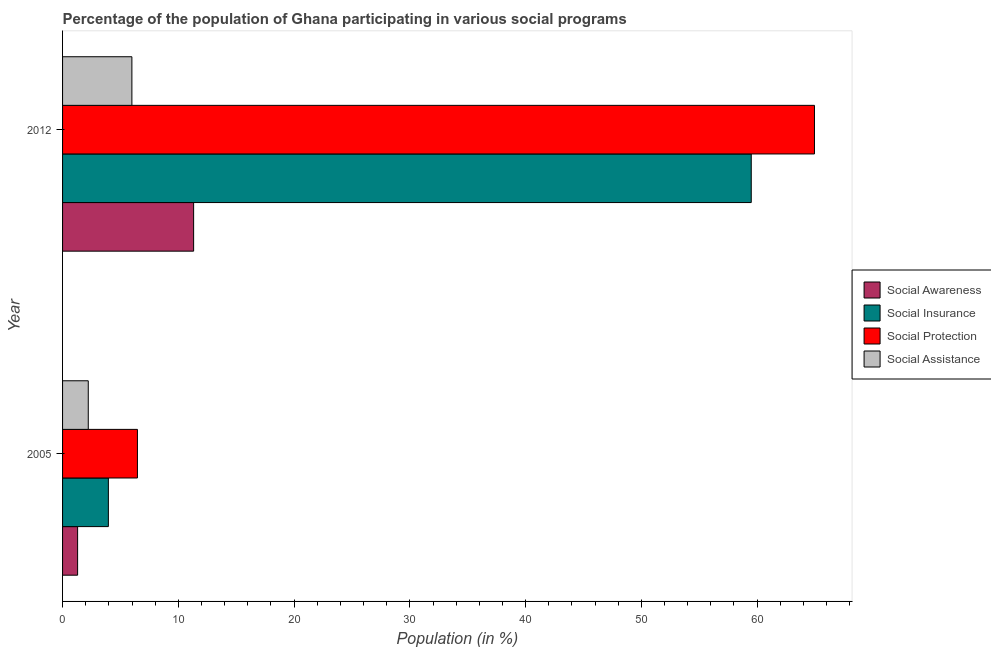How many different coloured bars are there?
Make the answer very short. 4. How many groups of bars are there?
Provide a short and direct response. 2. How many bars are there on the 1st tick from the top?
Give a very brief answer. 4. What is the participation of population in social protection programs in 2005?
Your answer should be very brief. 6.47. Across all years, what is the maximum participation of population in social protection programs?
Offer a terse response. 64.95. Across all years, what is the minimum participation of population in social awareness programs?
Offer a terse response. 1.3. In which year was the participation of population in social awareness programs maximum?
Provide a short and direct response. 2012. In which year was the participation of population in social protection programs minimum?
Ensure brevity in your answer.  2005. What is the total participation of population in social protection programs in the graph?
Give a very brief answer. 71.42. What is the difference between the participation of population in social insurance programs in 2005 and that in 2012?
Give a very brief answer. -55.53. What is the difference between the participation of population in social awareness programs in 2012 and the participation of population in social insurance programs in 2005?
Keep it short and to the point. 7.36. What is the average participation of population in social assistance programs per year?
Your answer should be compact. 4.11. In the year 2005, what is the difference between the participation of population in social protection programs and participation of population in social insurance programs?
Give a very brief answer. 2.51. In how many years, is the participation of population in social awareness programs greater than 44 %?
Provide a succinct answer. 0. What is the ratio of the participation of population in social awareness programs in 2005 to that in 2012?
Offer a very short reply. 0.12. What does the 1st bar from the top in 2012 represents?
Make the answer very short. Social Assistance. What does the 2nd bar from the bottom in 2005 represents?
Make the answer very short. Social Insurance. How many bars are there?
Offer a terse response. 8. How many years are there in the graph?
Provide a succinct answer. 2. What is the difference between two consecutive major ticks on the X-axis?
Give a very brief answer. 10. Are the values on the major ticks of X-axis written in scientific E-notation?
Your response must be concise. No. Does the graph contain grids?
Ensure brevity in your answer.  No. Where does the legend appear in the graph?
Offer a terse response. Center right. How many legend labels are there?
Your response must be concise. 4. How are the legend labels stacked?
Ensure brevity in your answer.  Vertical. What is the title of the graph?
Ensure brevity in your answer.  Percentage of the population of Ghana participating in various social programs . What is the Population (in %) of Social Awareness in 2005?
Offer a very short reply. 1.3. What is the Population (in %) of Social Insurance in 2005?
Your response must be concise. 3.96. What is the Population (in %) in Social Protection in 2005?
Give a very brief answer. 6.47. What is the Population (in %) in Social Assistance in 2005?
Give a very brief answer. 2.22. What is the Population (in %) of Social Awareness in 2012?
Your answer should be compact. 11.32. What is the Population (in %) of Social Insurance in 2012?
Offer a very short reply. 59.49. What is the Population (in %) of Social Protection in 2012?
Make the answer very short. 64.95. What is the Population (in %) of Social Assistance in 2012?
Provide a short and direct response. 5.99. Across all years, what is the maximum Population (in %) of Social Awareness?
Offer a very short reply. 11.32. Across all years, what is the maximum Population (in %) in Social Insurance?
Offer a terse response. 59.49. Across all years, what is the maximum Population (in %) of Social Protection?
Offer a terse response. 64.95. Across all years, what is the maximum Population (in %) in Social Assistance?
Give a very brief answer. 5.99. Across all years, what is the minimum Population (in %) of Social Awareness?
Offer a very short reply. 1.3. Across all years, what is the minimum Population (in %) of Social Insurance?
Offer a very short reply. 3.96. Across all years, what is the minimum Population (in %) of Social Protection?
Give a very brief answer. 6.47. Across all years, what is the minimum Population (in %) in Social Assistance?
Give a very brief answer. 2.22. What is the total Population (in %) of Social Awareness in the graph?
Ensure brevity in your answer.  12.62. What is the total Population (in %) of Social Insurance in the graph?
Your response must be concise. 63.45. What is the total Population (in %) in Social Protection in the graph?
Offer a very short reply. 71.42. What is the total Population (in %) in Social Assistance in the graph?
Make the answer very short. 8.21. What is the difference between the Population (in %) in Social Awareness in 2005 and that in 2012?
Your response must be concise. -10.02. What is the difference between the Population (in %) in Social Insurance in 2005 and that in 2012?
Offer a terse response. -55.53. What is the difference between the Population (in %) of Social Protection in 2005 and that in 2012?
Make the answer very short. -58.48. What is the difference between the Population (in %) of Social Assistance in 2005 and that in 2012?
Keep it short and to the point. -3.77. What is the difference between the Population (in %) of Social Awareness in 2005 and the Population (in %) of Social Insurance in 2012?
Keep it short and to the point. -58.19. What is the difference between the Population (in %) of Social Awareness in 2005 and the Population (in %) of Social Protection in 2012?
Offer a very short reply. -63.65. What is the difference between the Population (in %) in Social Awareness in 2005 and the Population (in %) in Social Assistance in 2012?
Offer a very short reply. -4.69. What is the difference between the Population (in %) of Social Insurance in 2005 and the Population (in %) of Social Protection in 2012?
Your answer should be very brief. -61. What is the difference between the Population (in %) in Social Insurance in 2005 and the Population (in %) in Social Assistance in 2012?
Ensure brevity in your answer.  -2.03. What is the difference between the Population (in %) of Social Protection in 2005 and the Population (in %) of Social Assistance in 2012?
Ensure brevity in your answer.  0.48. What is the average Population (in %) of Social Awareness per year?
Provide a succinct answer. 6.31. What is the average Population (in %) of Social Insurance per year?
Your response must be concise. 31.72. What is the average Population (in %) of Social Protection per year?
Offer a very short reply. 35.71. What is the average Population (in %) of Social Assistance per year?
Ensure brevity in your answer.  4.1. In the year 2005, what is the difference between the Population (in %) in Social Awareness and Population (in %) in Social Insurance?
Make the answer very short. -2.66. In the year 2005, what is the difference between the Population (in %) of Social Awareness and Population (in %) of Social Protection?
Offer a terse response. -5.17. In the year 2005, what is the difference between the Population (in %) of Social Awareness and Population (in %) of Social Assistance?
Offer a terse response. -0.92. In the year 2005, what is the difference between the Population (in %) of Social Insurance and Population (in %) of Social Protection?
Ensure brevity in your answer.  -2.51. In the year 2005, what is the difference between the Population (in %) in Social Insurance and Population (in %) in Social Assistance?
Your response must be concise. 1.74. In the year 2005, what is the difference between the Population (in %) of Social Protection and Population (in %) of Social Assistance?
Ensure brevity in your answer.  4.25. In the year 2012, what is the difference between the Population (in %) of Social Awareness and Population (in %) of Social Insurance?
Offer a very short reply. -48.17. In the year 2012, what is the difference between the Population (in %) in Social Awareness and Population (in %) in Social Protection?
Provide a short and direct response. -53.63. In the year 2012, what is the difference between the Population (in %) of Social Awareness and Population (in %) of Social Assistance?
Make the answer very short. 5.33. In the year 2012, what is the difference between the Population (in %) of Social Insurance and Population (in %) of Social Protection?
Give a very brief answer. -5.46. In the year 2012, what is the difference between the Population (in %) in Social Insurance and Population (in %) in Social Assistance?
Provide a short and direct response. 53.5. In the year 2012, what is the difference between the Population (in %) in Social Protection and Population (in %) in Social Assistance?
Provide a succinct answer. 58.96. What is the ratio of the Population (in %) of Social Awareness in 2005 to that in 2012?
Your answer should be very brief. 0.11. What is the ratio of the Population (in %) of Social Insurance in 2005 to that in 2012?
Provide a short and direct response. 0.07. What is the ratio of the Population (in %) of Social Protection in 2005 to that in 2012?
Provide a short and direct response. 0.1. What is the ratio of the Population (in %) of Social Assistance in 2005 to that in 2012?
Give a very brief answer. 0.37. What is the difference between the highest and the second highest Population (in %) of Social Awareness?
Your response must be concise. 10.02. What is the difference between the highest and the second highest Population (in %) of Social Insurance?
Make the answer very short. 55.53. What is the difference between the highest and the second highest Population (in %) of Social Protection?
Your answer should be compact. 58.48. What is the difference between the highest and the second highest Population (in %) of Social Assistance?
Make the answer very short. 3.77. What is the difference between the highest and the lowest Population (in %) of Social Awareness?
Ensure brevity in your answer.  10.02. What is the difference between the highest and the lowest Population (in %) of Social Insurance?
Offer a terse response. 55.53. What is the difference between the highest and the lowest Population (in %) in Social Protection?
Offer a very short reply. 58.48. What is the difference between the highest and the lowest Population (in %) in Social Assistance?
Offer a terse response. 3.77. 